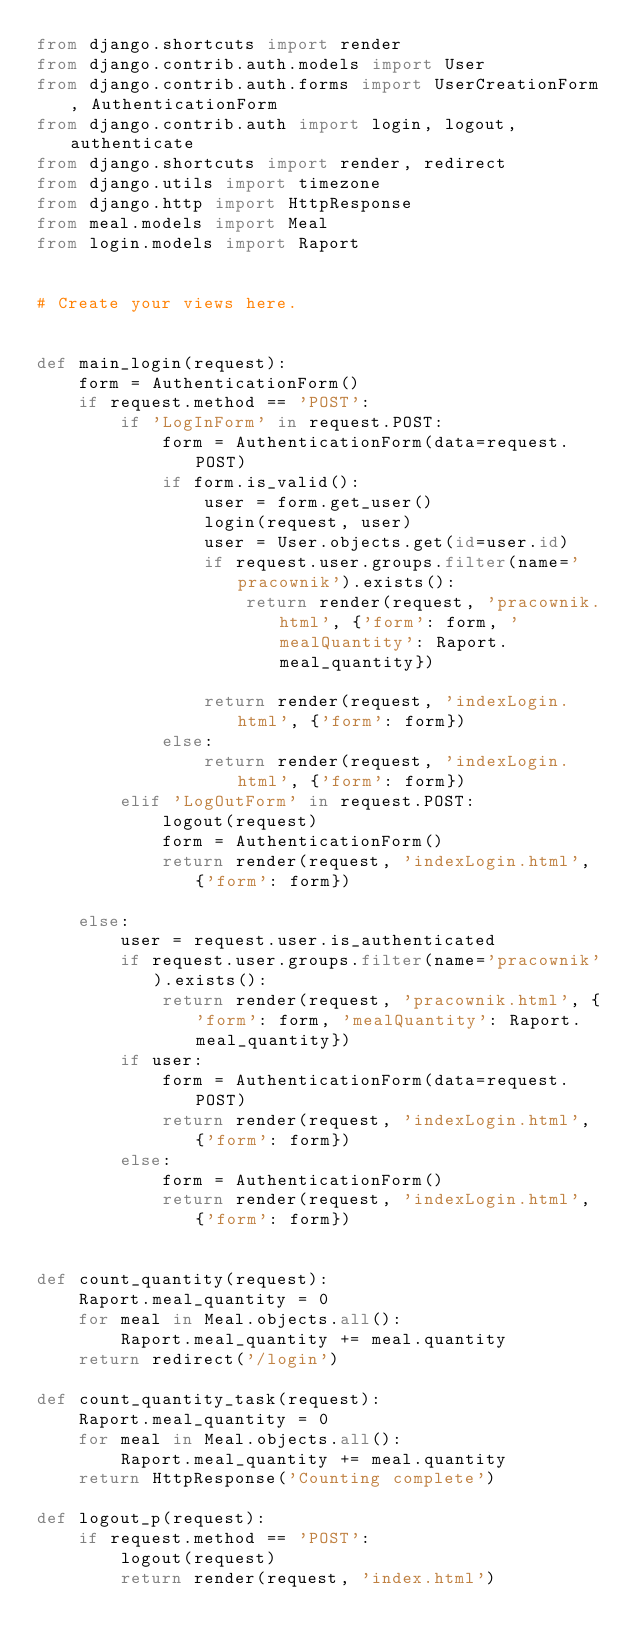Convert code to text. <code><loc_0><loc_0><loc_500><loc_500><_Python_>from django.shortcuts import render
from django.contrib.auth.models import User
from django.contrib.auth.forms import UserCreationForm, AuthenticationForm
from django.contrib.auth import login, logout, authenticate
from django.shortcuts import render, redirect
from django.utils import timezone
from django.http import HttpResponse
from meal.models import Meal
from login.models import Raport


# Create your views here.


def main_login(request):
    form = AuthenticationForm()
    if request.method == 'POST':
        if 'LogInForm' in request.POST:
            form = AuthenticationForm(data=request.POST)
            if form.is_valid():
                user = form.get_user()
                login(request, user)
                user = User.objects.get(id=user.id)
                if request.user.groups.filter(name='pracownik').exists():
                    return render(request, 'pracownik.html', {'form': form, 'mealQuantity': Raport.meal_quantity})

                return render(request, 'indexLogin.html', {'form': form})
            else:
                return render(request, 'indexLogin.html', {'form': form})
        elif 'LogOutForm' in request.POST:
            logout(request)
            form = AuthenticationForm()
            return render(request, 'indexLogin.html', {'form': form})

    else:
        user = request.user.is_authenticated
        if request.user.groups.filter(name='pracownik').exists():
            return render(request, 'pracownik.html', {'form': form, 'mealQuantity': Raport.meal_quantity})
        if user:
            form = AuthenticationForm(data=request.POST)
            return render(request, 'indexLogin.html', {'form': form})
        else:
            form = AuthenticationForm()
            return render(request, 'indexLogin.html', {'form': form})


def count_quantity(request):
    Raport.meal_quantity = 0
    for meal in Meal.objects.all():
        Raport.meal_quantity += meal.quantity
    return redirect('/login')

def count_quantity_task(request):
    Raport.meal_quantity = 0
    for meal in Meal.objects.all():
        Raport.meal_quantity += meal.quantity
    return HttpResponse('Counting complete')
    
def logout_p(request):
    if request.method == 'POST':
        logout(request)
        return render(request, 'index.html')
</code> 